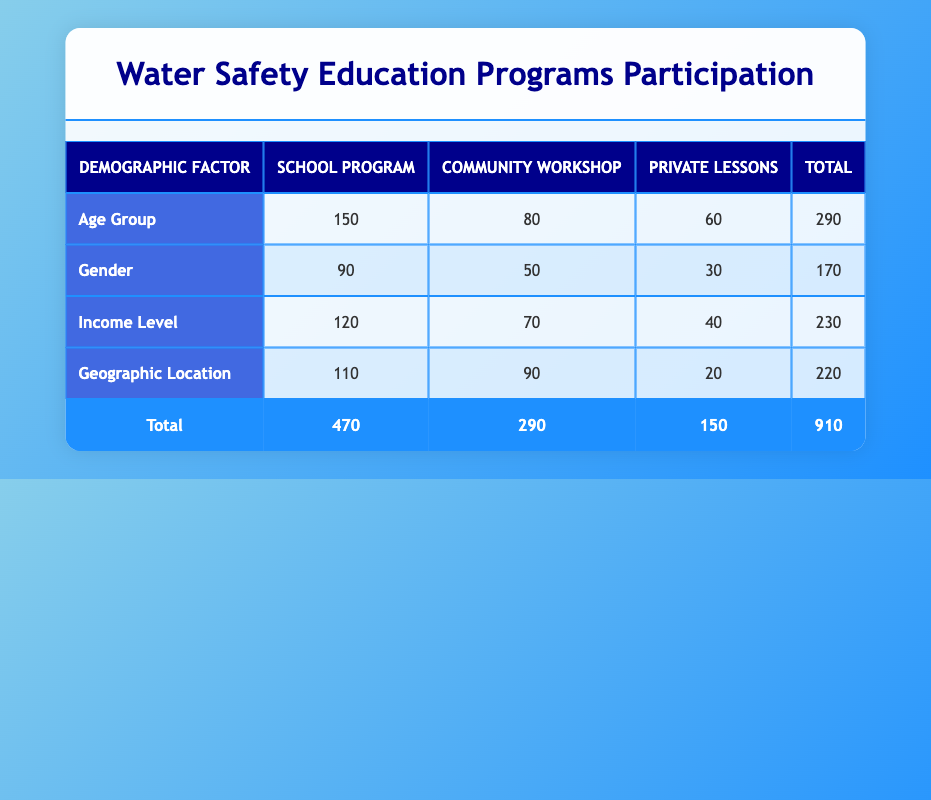What is the total number of participants in the School Program? The table shows that the total number of participants in the School Program is listed under the 'School Program' column. Adding the participants for each demographic factor gives 150 (Age Group) + 90 (Gender) + 120 (Income Level) + 110 (Geographic Location) = 470.
Answer: 470 Which program type has the least number of participants based on the data? Looking at each program's total participants, the Private Lessons have 60 (Age Group) + 30 (Gender) + 40 (Income Level) + 20 (Geographic Location) = 150, which is less than the other program types (School Program: 470, Community Workshop: 290).
Answer: Private Lessons Is the number of participants in the Community Workshop higher than those in the Private Lessons? By comparing the totals, the Community Workshop has 80 (Age Group) + 50 (Gender) + 70 (Income Level) + 90 (Geographic Location) = 290, while Private Lessons total 150. Since 290 is greater than 150, the statement is true.
Answer: Yes What is the difference in participants between the School Program and Community Workshop? To find the difference, first identify the total participants for each program. The School Program has 470, and the Community Workshop has 290. The difference is 470 - 290 = 180.
Answer: 180 Are there more participants in the School Program than in the Geographic Location demographic category? The School Program has a total of 470 participants, while the Geographic Location demographic category has 110. Since 470 is greater than 110, the statement is true.
Answer: Yes What percentage of the total participants are from the Income Level category participating in the School Program? Start by calculating the total number of participants in the School Program (470) and the number from the Income Level category (120). To find the percentage, use the formula (120 / 470) * 100. This equals approximately 25.53%.
Answer: 25.53% Which has more participants: the Gender demographic in the Community Workshop or the Age Group demographic in the School Program? The Gender demographic in the Community Workshop has 50 participants, while the Age Group demographic in the School Program has 150 participants. Since 150 is greater than 50, the Age Group in the School Program has more participants.
Answer: Age Group in School Program Calculate the total number of participants across all program types for the Age Group demographic. Sum the number of participants in each program type under the Age Group demographic: 150 (School Program) + 80 (Community Workshop) + 60 (Private Lessons) = 290.
Answer: 290 